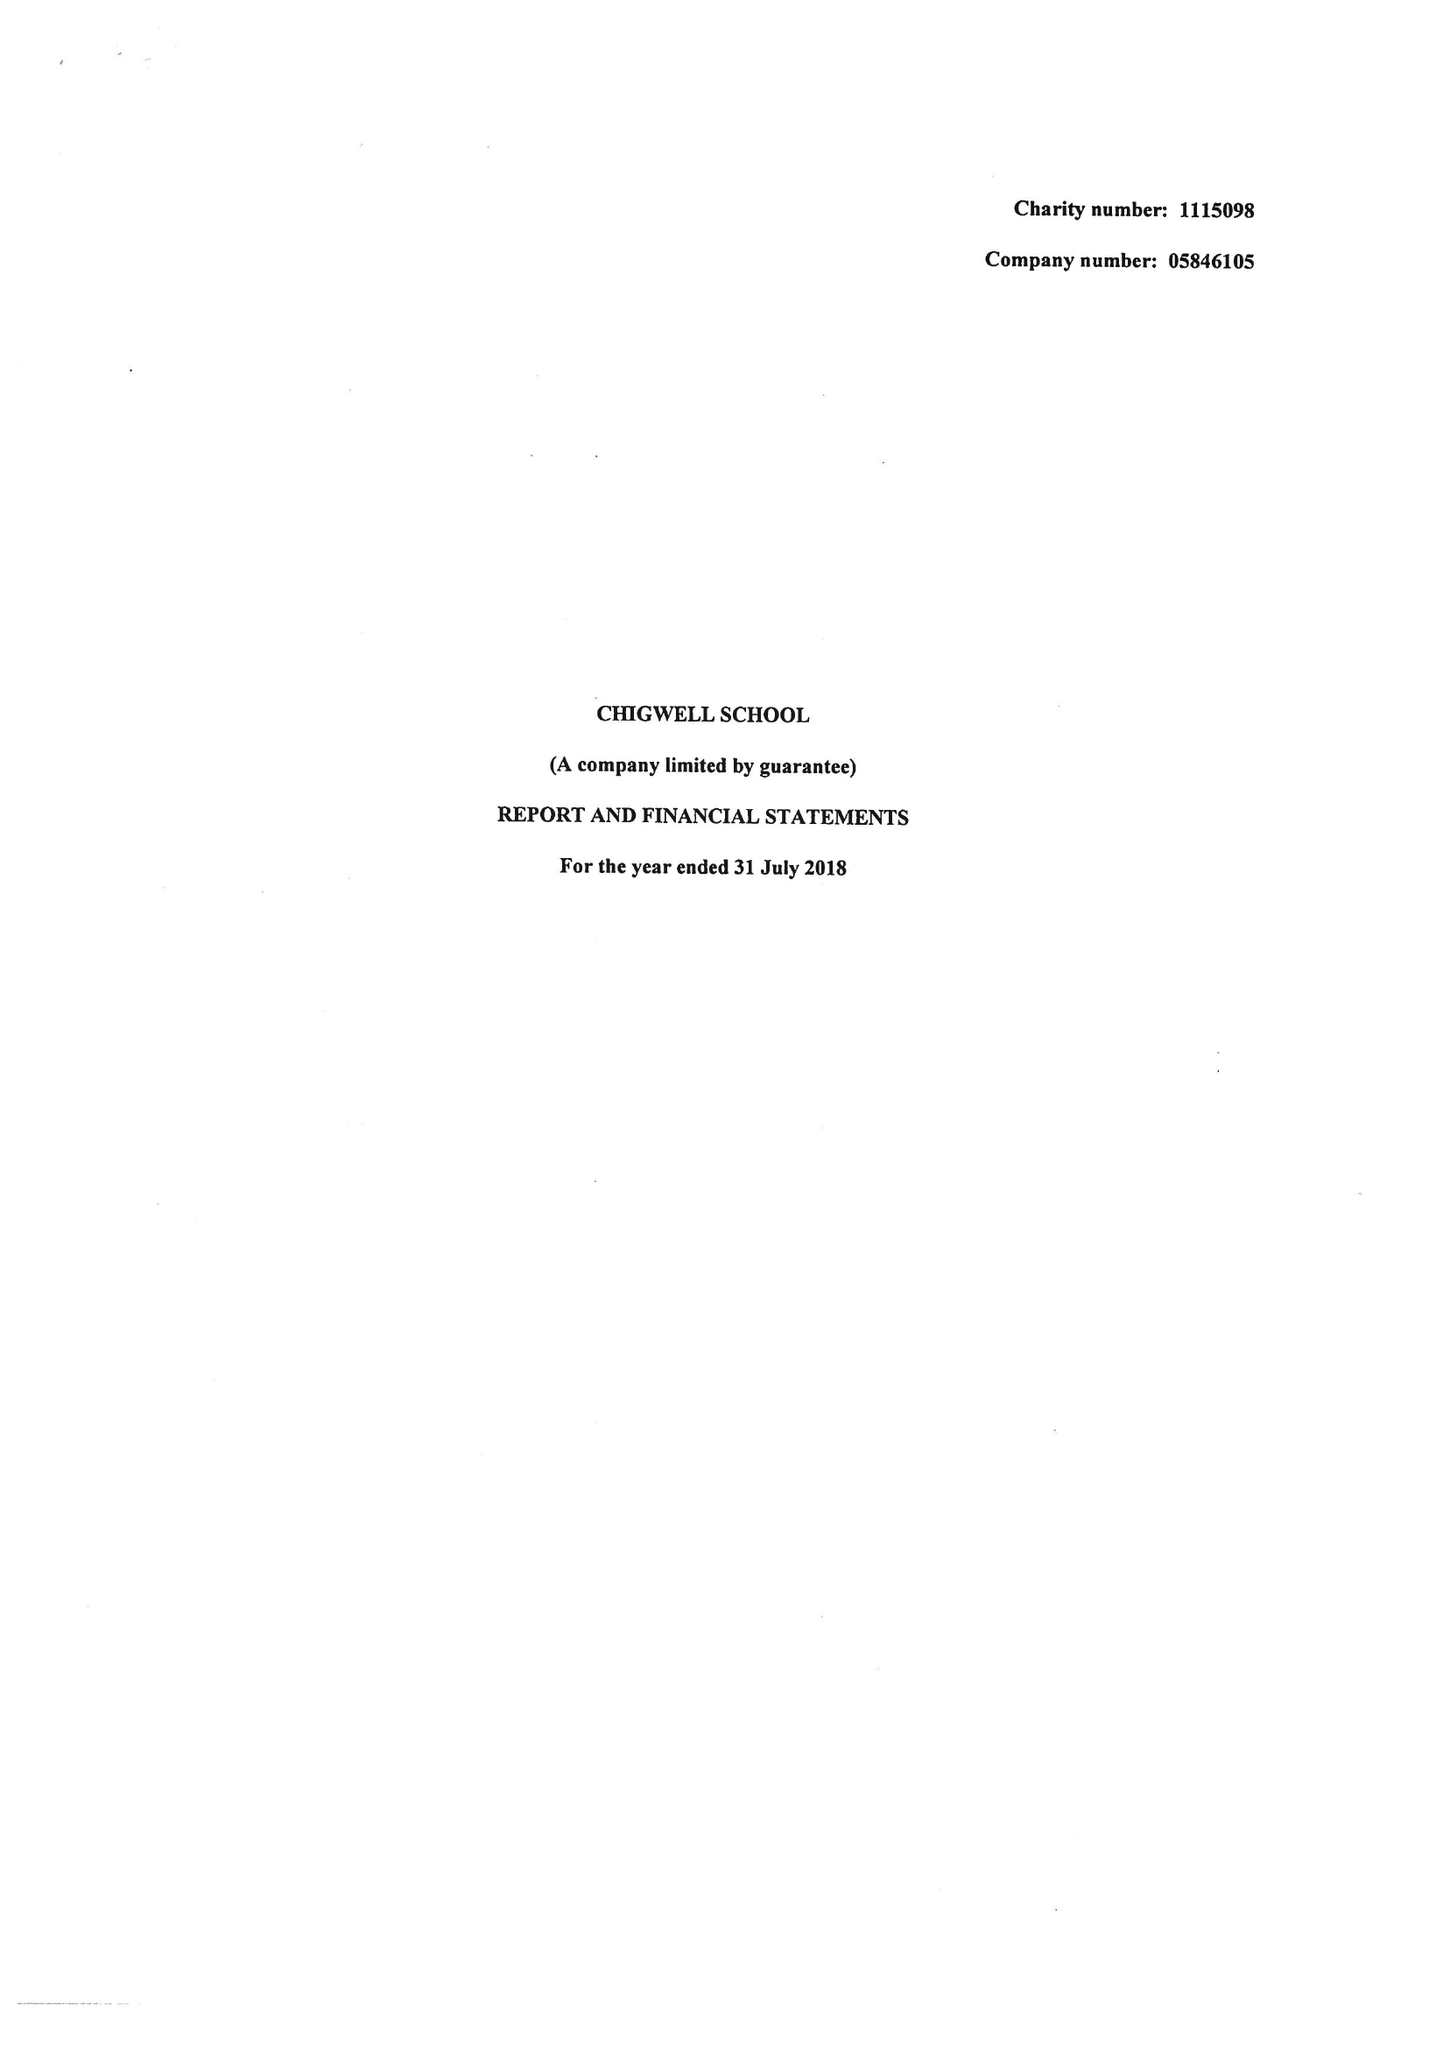What is the value for the charity_name?
Answer the question using a single word or phrase. Chigwell School 